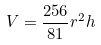<formula> <loc_0><loc_0><loc_500><loc_500>V = \frac { 2 5 6 } { 8 1 } r ^ { 2 } h</formula> 